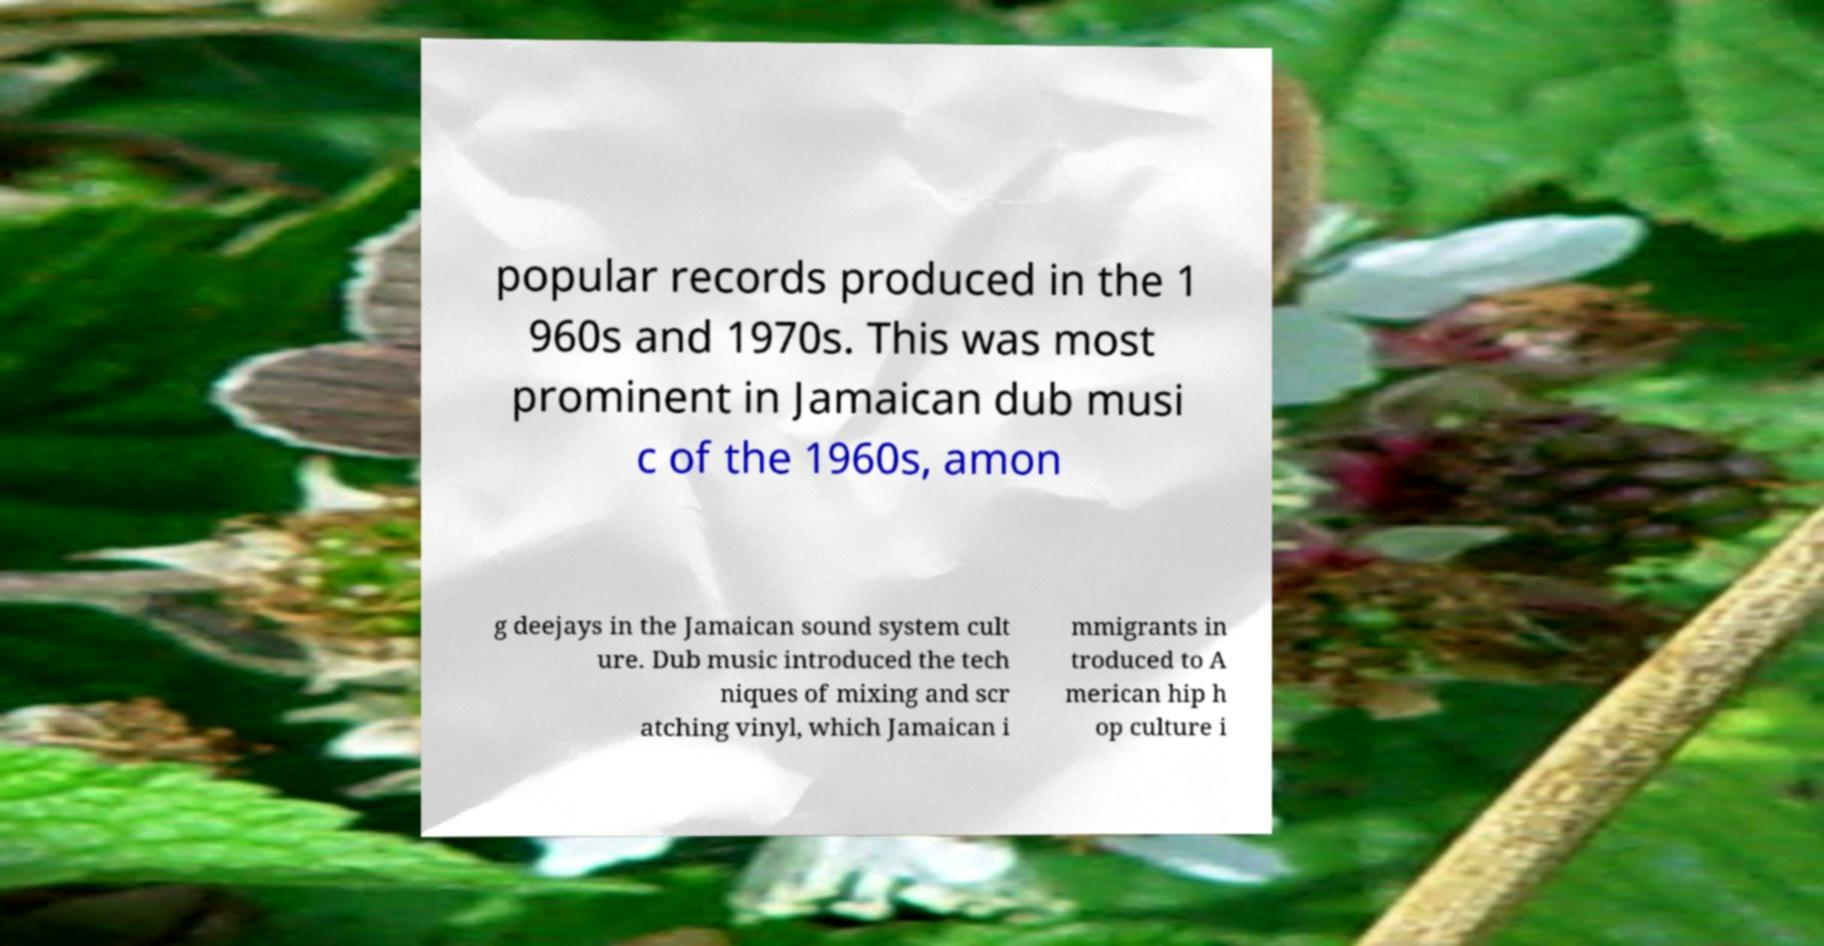I need the written content from this picture converted into text. Can you do that? popular records produced in the 1 960s and 1970s. This was most prominent in Jamaican dub musi c of the 1960s, amon g deejays in the Jamaican sound system cult ure. Dub music introduced the tech niques of mixing and scr atching vinyl, which Jamaican i mmigrants in troduced to A merican hip h op culture i 